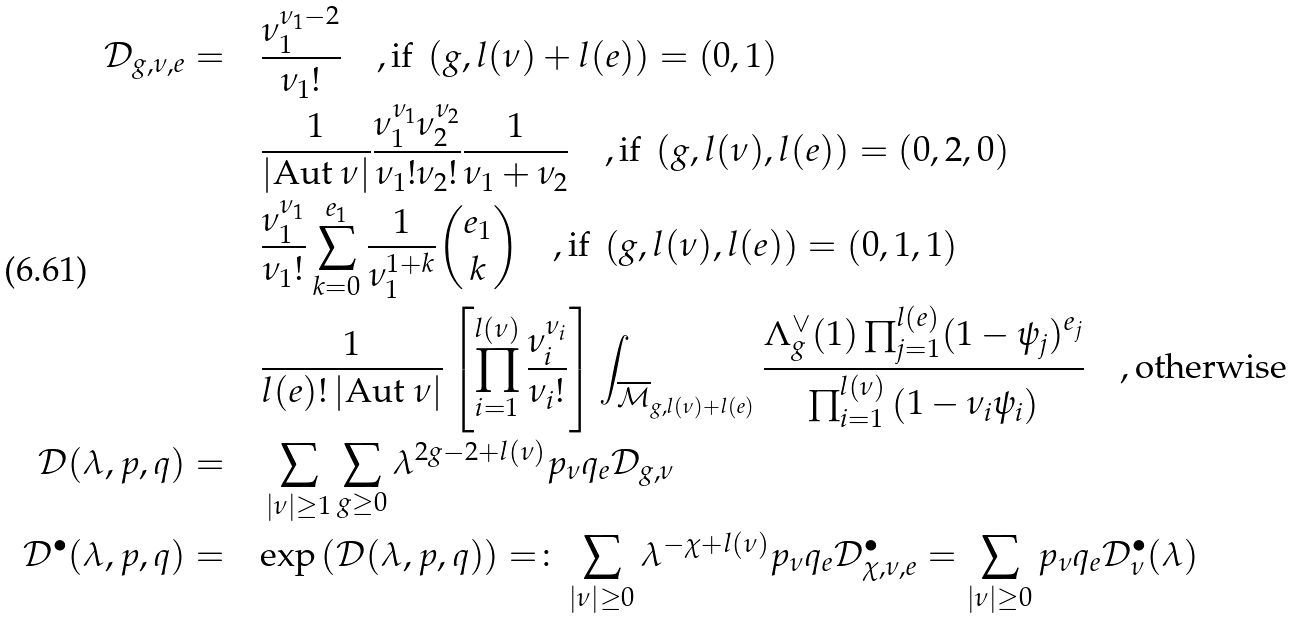<formula> <loc_0><loc_0><loc_500><loc_500>\mathcal { D } _ { g , \nu , e } = \quad & \frac { \nu _ { 1 } ^ { \nu _ { 1 } - 2 } } { \nu _ { 1 } ! } \quad , \text {if } \left ( g , l ( \nu ) + l ( e ) \right ) = \left ( 0 , 1 \right ) \\ & \frac { 1 } { | \text {Aut } \nu | } \frac { \nu _ { 1 } ^ { \nu _ { 1 } } \nu _ { 2 } ^ { \nu _ { 2 } } } { \nu _ { 1 } ! \nu _ { 2 } ! } \frac { 1 } { \nu _ { 1 } + \nu _ { 2 } } \quad , \text {if } \left ( g , l ( \nu ) , l ( e ) \right ) = \left ( 0 , 2 , 0 \right ) \\ & \frac { \nu _ { 1 } ^ { \nu _ { 1 } } } { \nu _ { 1 } ! } \sum _ { k = 0 } ^ { e _ { 1 } } \frac { 1 } { \nu _ { 1 } ^ { 1 + k } } { e _ { 1 } \choose k } \quad , \text {if } \left ( g , l ( \nu ) , l ( e ) \right ) = \left ( 0 , 1 , 1 \right ) \\ & \frac { 1 } { l ( e ) ! \, | \text {Aut } \nu | } \left [ \prod _ { i = 1 } ^ { l ( \nu ) } \frac { \nu _ { i } ^ { \nu _ { i } } } { \nu _ { i } ! } \right ] \int _ { \overline { \mathcal { M } } _ { g , l ( \nu ) + l ( e ) } } \frac { \Lambda _ { g } ^ { \vee } ( 1 ) \prod _ { j = 1 } ^ { l ( e ) } ( 1 - \psi _ { j } ) ^ { e _ { j } } } { \prod _ { i = 1 } ^ { l ( \nu ) } \left ( 1 - \nu _ { i } \psi _ { i } \right ) } \quad , \text {otherwise} \\ \mathcal { D } ( \lambda , p , q ) = \quad & \sum _ { | \nu | \geq 1 } \sum _ { g \geq 0 } \lambda ^ { 2 g - 2 + l ( \nu ) } p _ { \nu } q _ { e } \mathcal { D } _ { g , \nu } \\ \mathcal { D } ^ { \bullet } ( \lambda , p , q ) = \quad & \text {exp} \left ( \mathcal { D } ( \lambda , p , q ) \right ) = \colon \sum _ { | \nu | \geq 0 } \lambda ^ { - \chi + l ( \nu ) } p _ { \nu } q _ { e } \mathcal { D } ^ { \bullet } _ { \chi , \nu , e } = \sum _ { | \nu | \geq 0 } p _ { \nu } q _ { e } \mathcal { D } ^ { \bullet } _ { \nu } ( \lambda )</formula> 